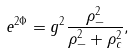Convert formula to latex. <formula><loc_0><loc_0><loc_500><loc_500>e ^ { 2 \Phi } = g ^ { 2 } \frac { \rho _ { - } ^ { 2 } } { \rho _ { - } ^ { 2 } + \rho _ { c } ^ { 2 } } ,</formula> 